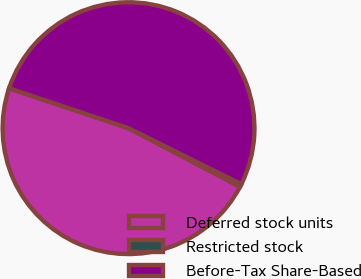Convert chart. <chart><loc_0><loc_0><loc_500><loc_500><pie_chart><fcel>Deferred stock units<fcel>Restricted stock<fcel>Before-Tax Share-Based<nl><fcel>47.43%<fcel>0.37%<fcel>52.2%<nl></chart> 